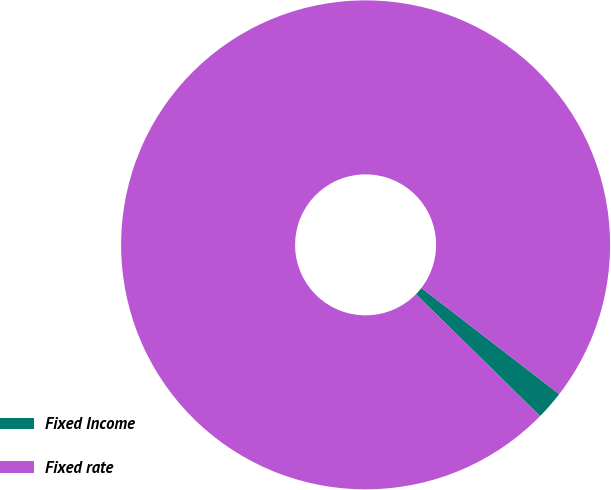Convert chart. <chart><loc_0><loc_0><loc_500><loc_500><pie_chart><fcel>Fixed Income<fcel>Fixed rate<nl><fcel>1.9%<fcel>98.1%<nl></chart> 